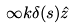<formula> <loc_0><loc_0><loc_500><loc_500>\infty k \delta ( s ) \hat { z }</formula> 